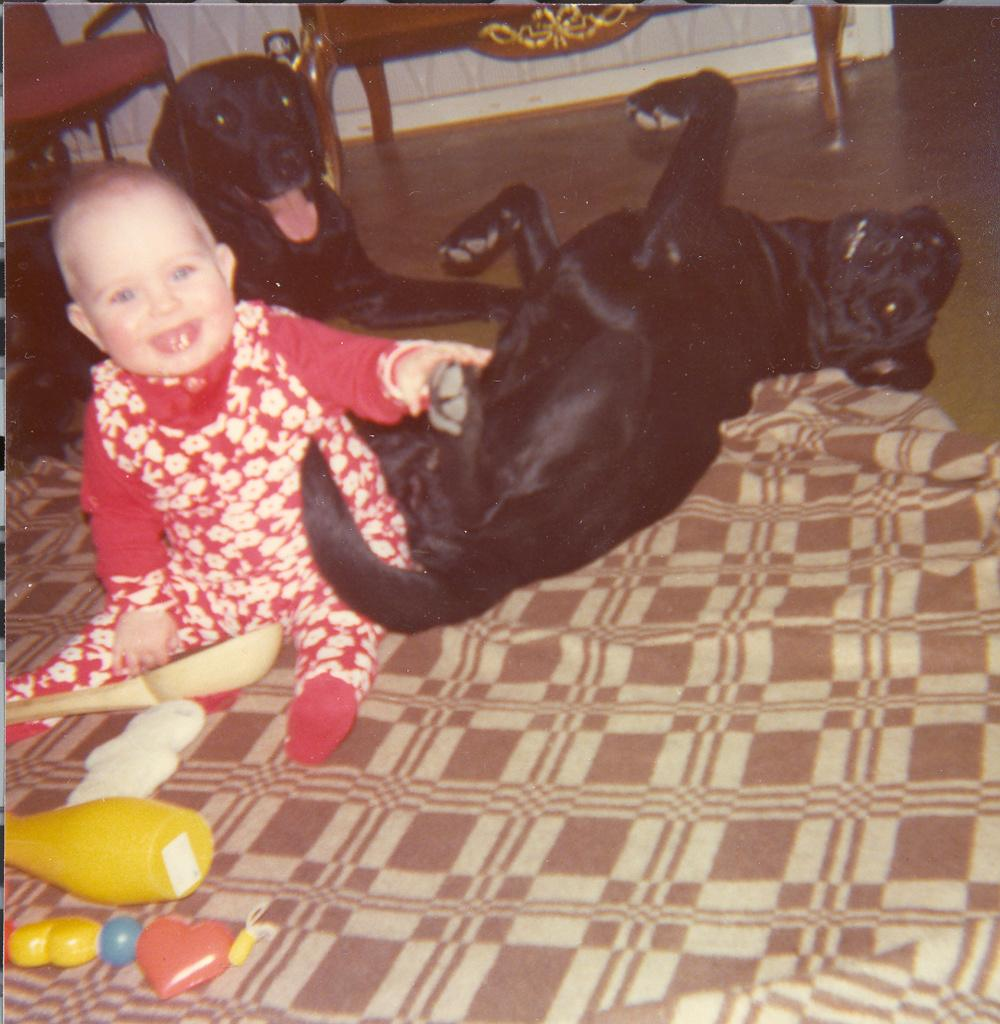Who or what is the main subject in the image? There is a child in the image. What animals are present in the image? There are two black color dogs in the image. Where are the child and dogs located? The child and dogs are on the floor in the image. What type of object can be seen in the image? There is a cloth in the image. What piece of furniture is visible in the image? There is a chair in the image. What else can be found in the image besides the child, dogs, cloth, and chair? There are toys and other objects in the image. What advice does the cat give to the child in the image? There is no cat present in the image, so no advice can be given. 